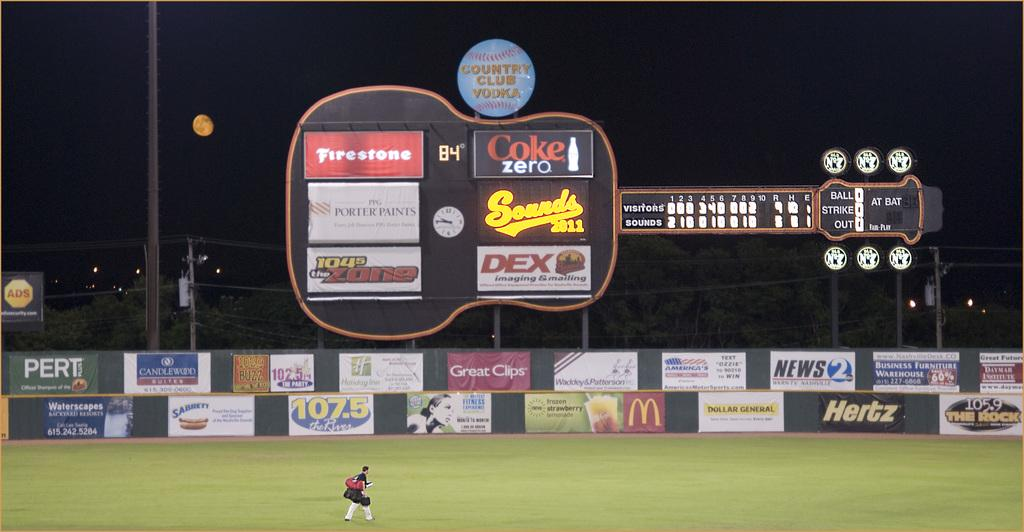<image>
Summarize the visual content of the image. Scoreboard at a baseball game which is sponsored by COke Zero. 